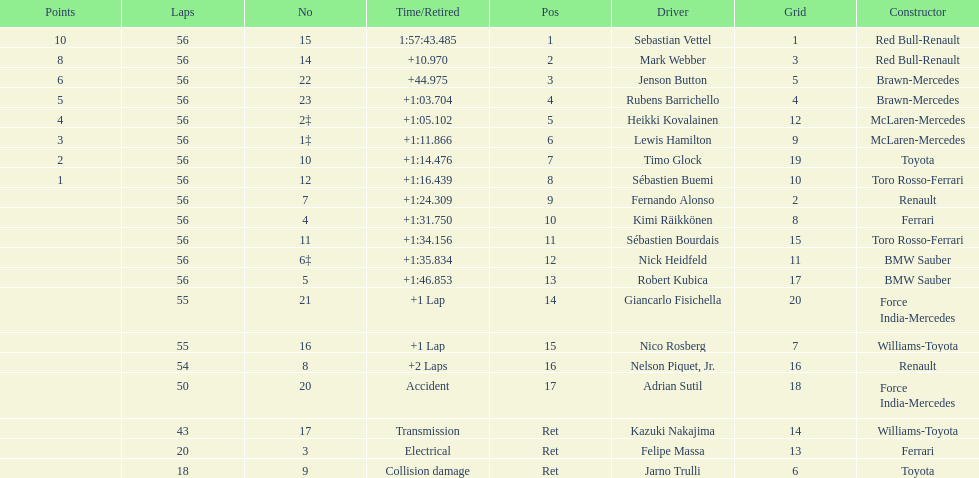Why did the  toyota retire Collision damage. What was the drivers name? Jarno Trulli. 